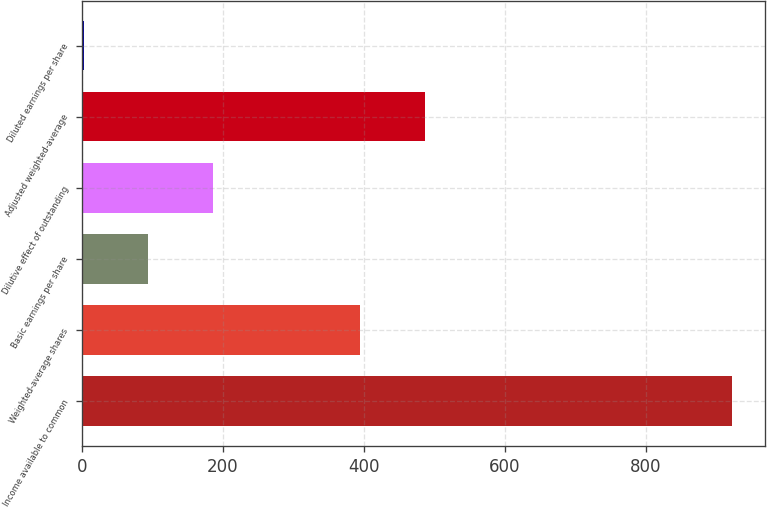Convert chart to OTSL. <chart><loc_0><loc_0><loc_500><loc_500><bar_chart><fcel>Income available to common<fcel>Weighted-average shares<fcel>Basic earnings per share<fcel>Dilutive effect of outstanding<fcel>Adjusted weighted-average<fcel>Diluted earnings per share<nl><fcel>923<fcel>394.2<fcel>94.38<fcel>186.45<fcel>486.27<fcel>2.31<nl></chart> 